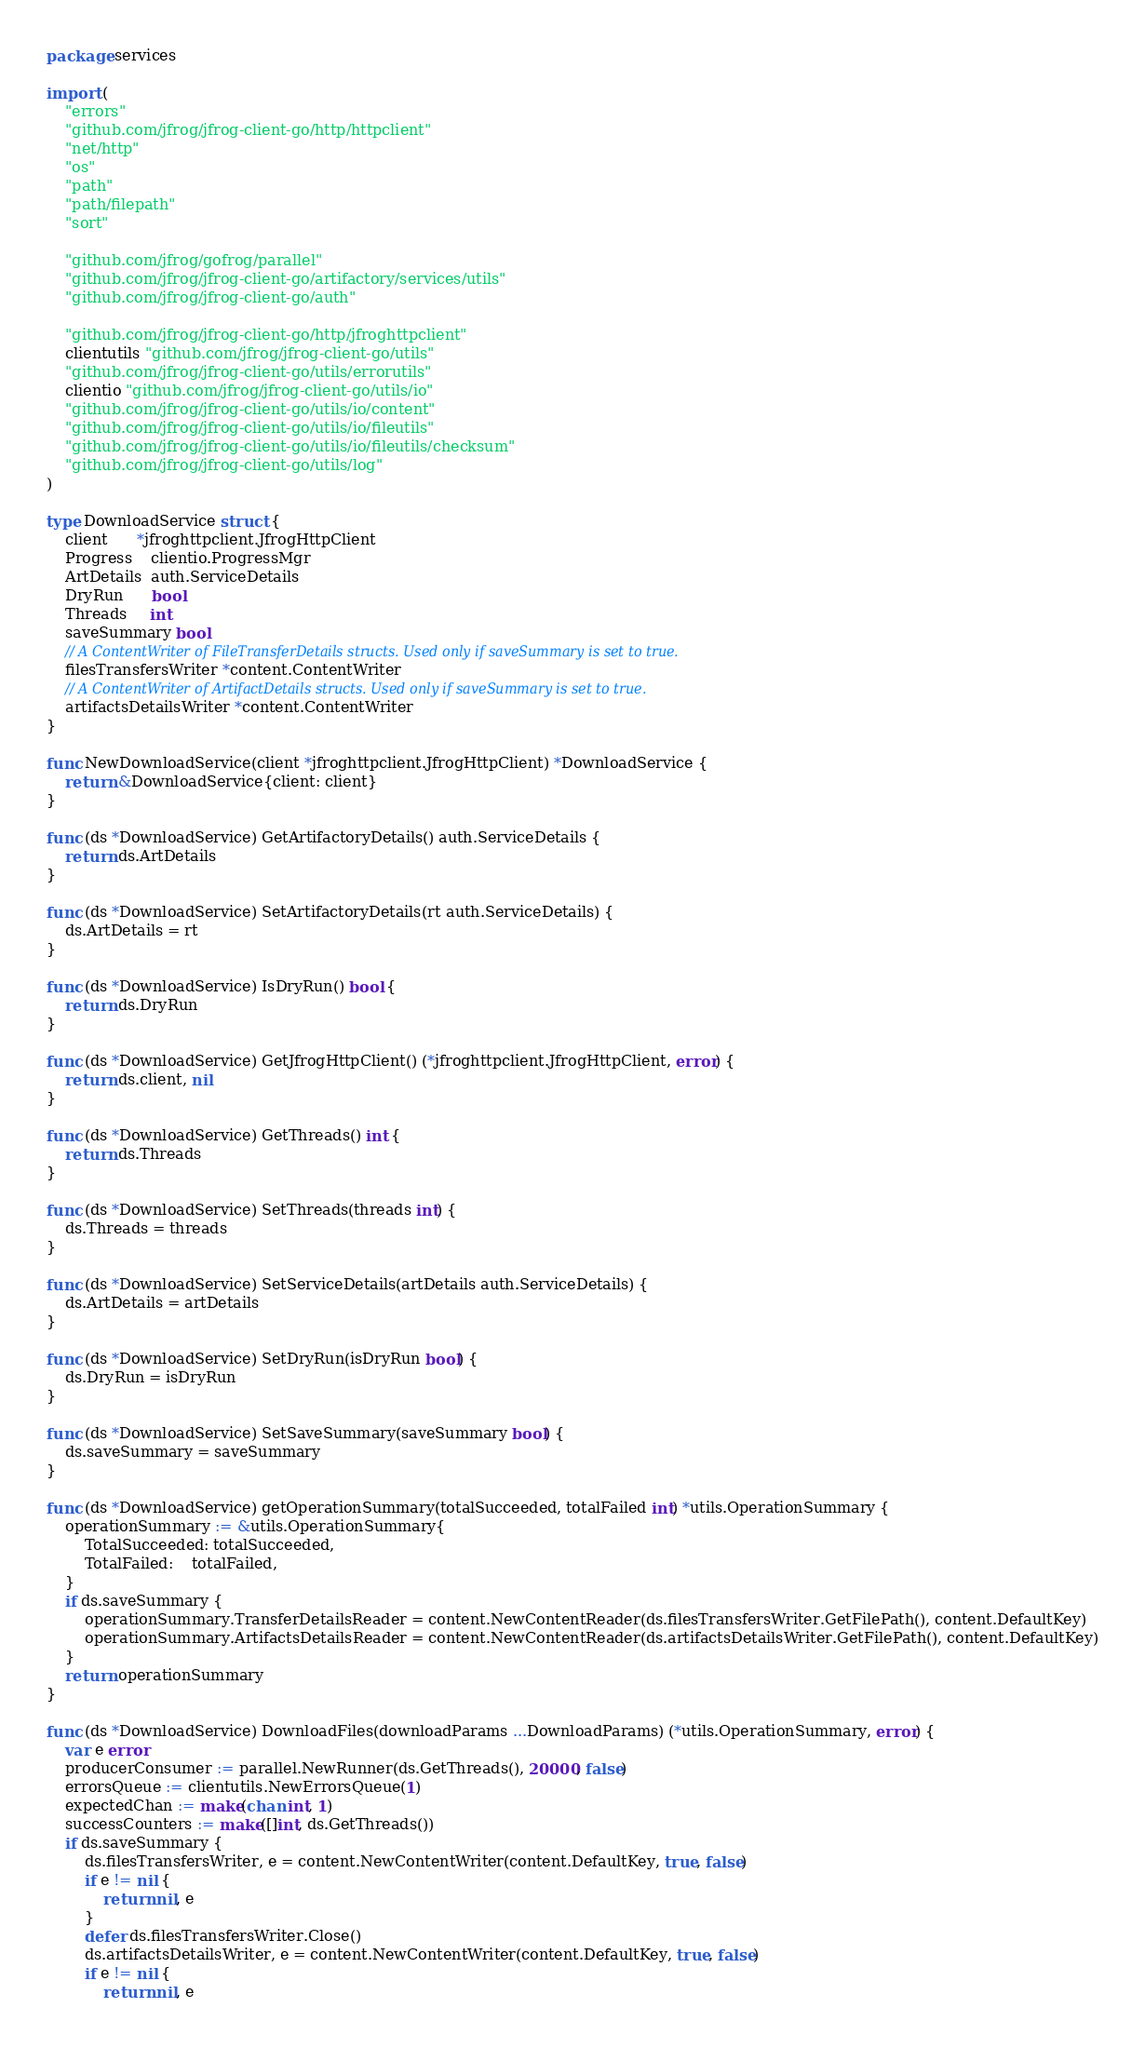Convert code to text. <code><loc_0><loc_0><loc_500><loc_500><_Go_>package services

import (
	"errors"
	"github.com/jfrog/jfrog-client-go/http/httpclient"
	"net/http"
	"os"
	"path"
	"path/filepath"
	"sort"

	"github.com/jfrog/gofrog/parallel"
	"github.com/jfrog/jfrog-client-go/artifactory/services/utils"
	"github.com/jfrog/jfrog-client-go/auth"

	"github.com/jfrog/jfrog-client-go/http/jfroghttpclient"
	clientutils "github.com/jfrog/jfrog-client-go/utils"
	"github.com/jfrog/jfrog-client-go/utils/errorutils"
	clientio "github.com/jfrog/jfrog-client-go/utils/io"
	"github.com/jfrog/jfrog-client-go/utils/io/content"
	"github.com/jfrog/jfrog-client-go/utils/io/fileutils"
	"github.com/jfrog/jfrog-client-go/utils/io/fileutils/checksum"
	"github.com/jfrog/jfrog-client-go/utils/log"
)

type DownloadService struct {
	client      *jfroghttpclient.JfrogHttpClient
	Progress    clientio.ProgressMgr
	ArtDetails  auth.ServiceDetails
	DryRun      bool
	Threads     int
	saveSummary bool
	// A ContentWriter of FileTransferDetails structs. Used only if saveSummary is set to true.
	filesTransfersWriter *content.ContentWriter
	// A ContentWriter of ArtifactDetails structs. Used only if saveSummary is set to true.
	artifactsDetailsWriter *content.ContentWriter
}

func NewDownloadService(client *jfroghttpclient.JfrogHttpClient) *DownloadService {
	return &DownloadService{client: client}
}

func (ds *DownloadService) GetArtifactoryDetails() auth.ServiceDetails {
	return ds.ArtDetails
}

func (ds *DownloadService) SetArtifactoryDetails(rt auth.ServiceDetails) {
	ds.ArtDetails = rt
}

func (ds *DownloadService) IsDryRun() bool {
	return ds.DryRun
}

func (ds *DownloadService) GetJfrogHttpClient() (*jfroghttpclient.JfrogHttpClient, error) {
	return ds.client, nil
}

func (ds *DownloadService) GetThreads() int {
	return ds.Threads
}

func (ds *DownloadService) SetThreads(threads int) {
	ds.Threads = threads
}

func (ds *DownloadService) SetServiceDetails(artDetails auth.ServiceDetails) {
	ds.ArtDetails = artDetails
}

func (ds *DownloadService) SetDryRun(isDryRun bool) {
	ds.DryRun = isDryRun
}

func (ds *DownloadService) SetSaveSummary(saveSummary bool) {
	ds.saveSummary = saveSummary
}

func (ds *DownloadService) getOperationSummary(totalSucceeded, totalFailed int) *utils.OperationSummary {
	operationSummary := &utils.OperationSummary{
		TotalSucceeded: totalSucceeded,
		TotalFailed:    totalFailed,
	}
	if ds.saveSummary {
		operationSummary.TransferDetailsReader = content.NewContentReader(ds.filesTransfersWriter.GetFilePath(), content.DefaultKey)
		operationSummary.ArtifactsDetailsReader = content.NewContentReader(ds.artifactsDetailsWriter.GetFilePath(), content.DefaultKey)
	}
	return operationSummary
}

func (ds *DownloadService) DownloadFiles(downloadParams ...DownloadParams) (*utils.OperationSummary, error) {
	var e error
	producerConsumer := parallel.NewRunner(ds.GetThreads(), 20000, false)
	errorsQueue := clientutils.NewErrorsQueue(1)
	expectedChan := make(chan int, 1)
	successCounters := make([]int, ds.GetThreads())
	if ds.saveSummary {
		ds.filesTransfersWriter, e = content.NewContentWriter(content.DefaultKey, true, false)
		if e != nil {
			return nil, e
		}
		defer ds.filesTransfersWriter.Close()
		ds.artifactsDetailsWriter, e = content.NewContentWriter(content.DefaultKey, true, false)
		if e != nil {
			return nil, e</code> 